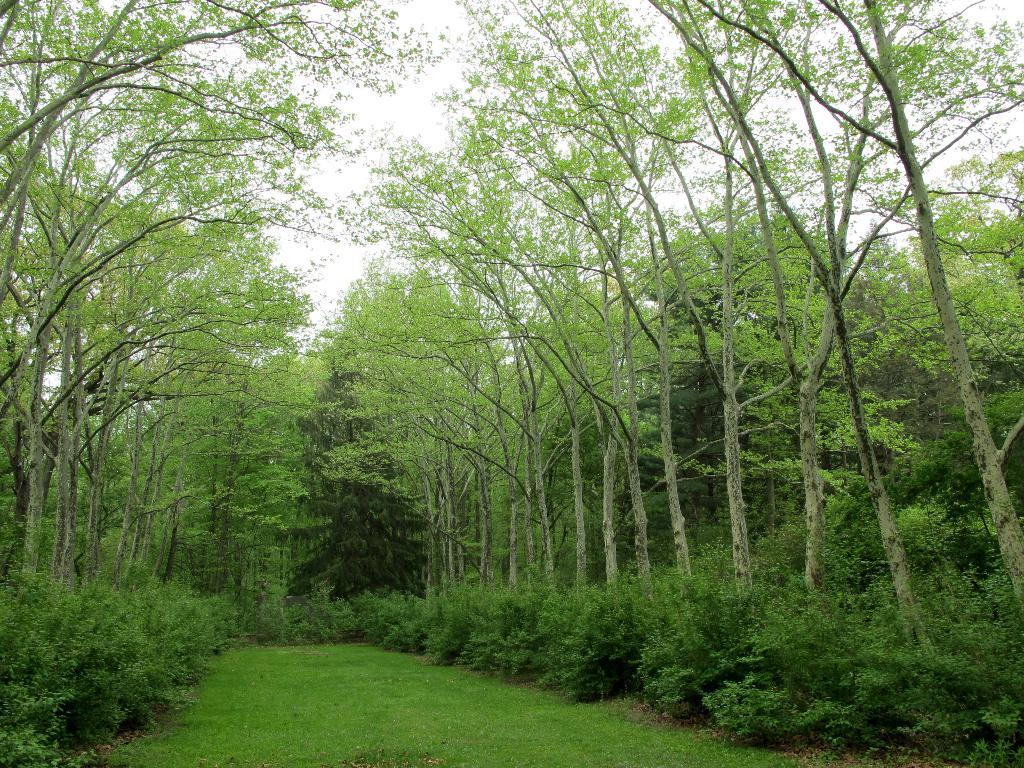What type of vegetation can be seen in the image? There is greenery in the image. Where is the greenery located in the image? The greenery is around the area of the image. What type of landscape is visible at the bottom side of the image? There is a grassland at the bottom side of the image. Are there any dinosaurs visible in the grassland at the bottom side of the image? There are no dinosaurs present in the image; it features greenery and a grassland. What scientific experiments are being conducted in the image? There is no indication of any scientific experiments being conducted in the image. 